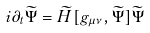Convert formula to latex. <formula><loc_0><loc_0><loc_500><loc_500>i \partial _ { t } \widetilde { \Psi } = \widetilde { H } [ g _ { \mu \nu } , \widetilde { \Psi } ] \widetilde { \Psi }</formula> 